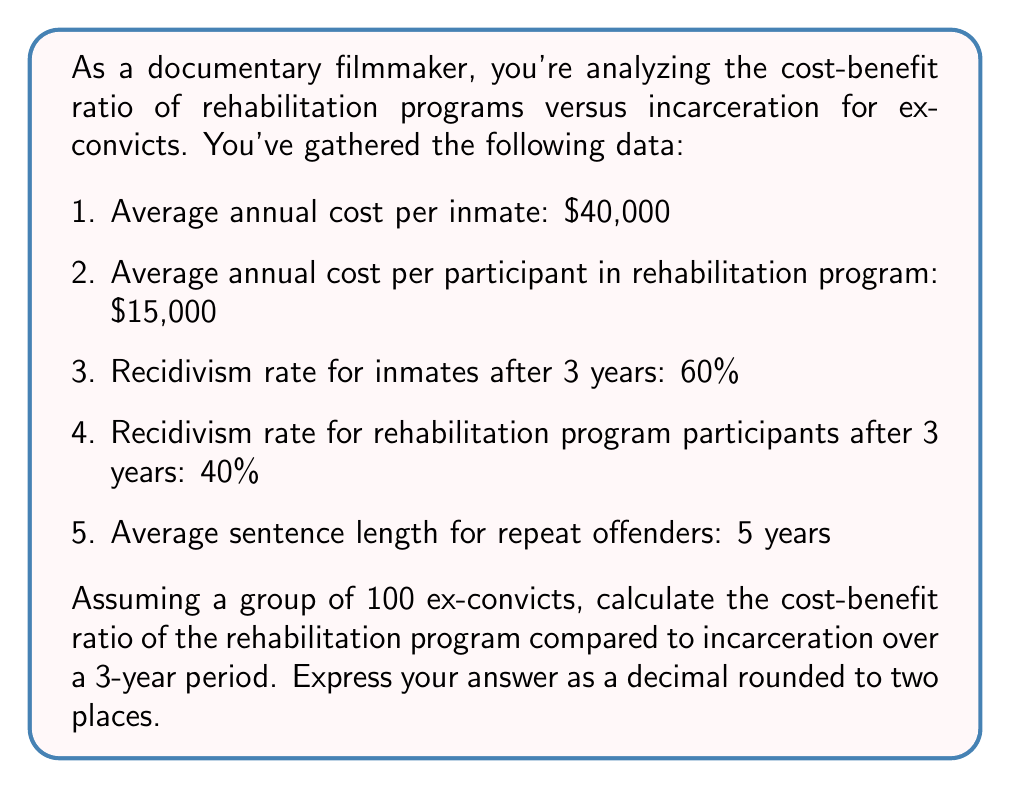Could you help me with this problem? Let's break this down step-by-step:

1. Calculate the total cost for 100 people in the rehabilitation program for 3 years:
   $$C_{rehab} = 100 \times $15,000 \times 3 = $4,500,000$$

2. Calculate the number of people who reoffend in each group after 3 years:
   Rehabilitation: $$R_{rehab} = 100 \times 0.40 = 40$$
   Incarceration: $$R_{inc} = 100 \times 0.60 = 60$$

3. Calculate the cost of incarcerating the reoffenders for 5 years:
   Rehabilitation: $$C_{rehab\_reoffend} = 40 \times $40,000 \times 5 = $8,000,000$$
   Incarceration: $$C_{inc\_reoffend} = 60 \times $40,000 \times 5 = $12,000,000$$

4. Calculate the total cost for the rehabilitation approach:
   $$T_{rehab} = C_{rehab} + C_{rehab\_reoffend} = $4,500,000 + $8,000,000 = $12,500,000$$

5. Calculate the total cost for the incarceration approach:
   $$T_{inc} = 100 \times $40,000 \times 3 + C_{inc\_reoffend} = $12,000,000 + $12,000,000 = $24,000,000$$

6. Calculate the cost-benefit ratio:
   $$\text{Cost-Benefit Ratio} = \frac{T_{rehab}}{T_{inc}} = \frac{$12,500,000}{$24,000,000} = 0.5208$$

Rounded to two decimal places: 0.52
Answer: 0.52 